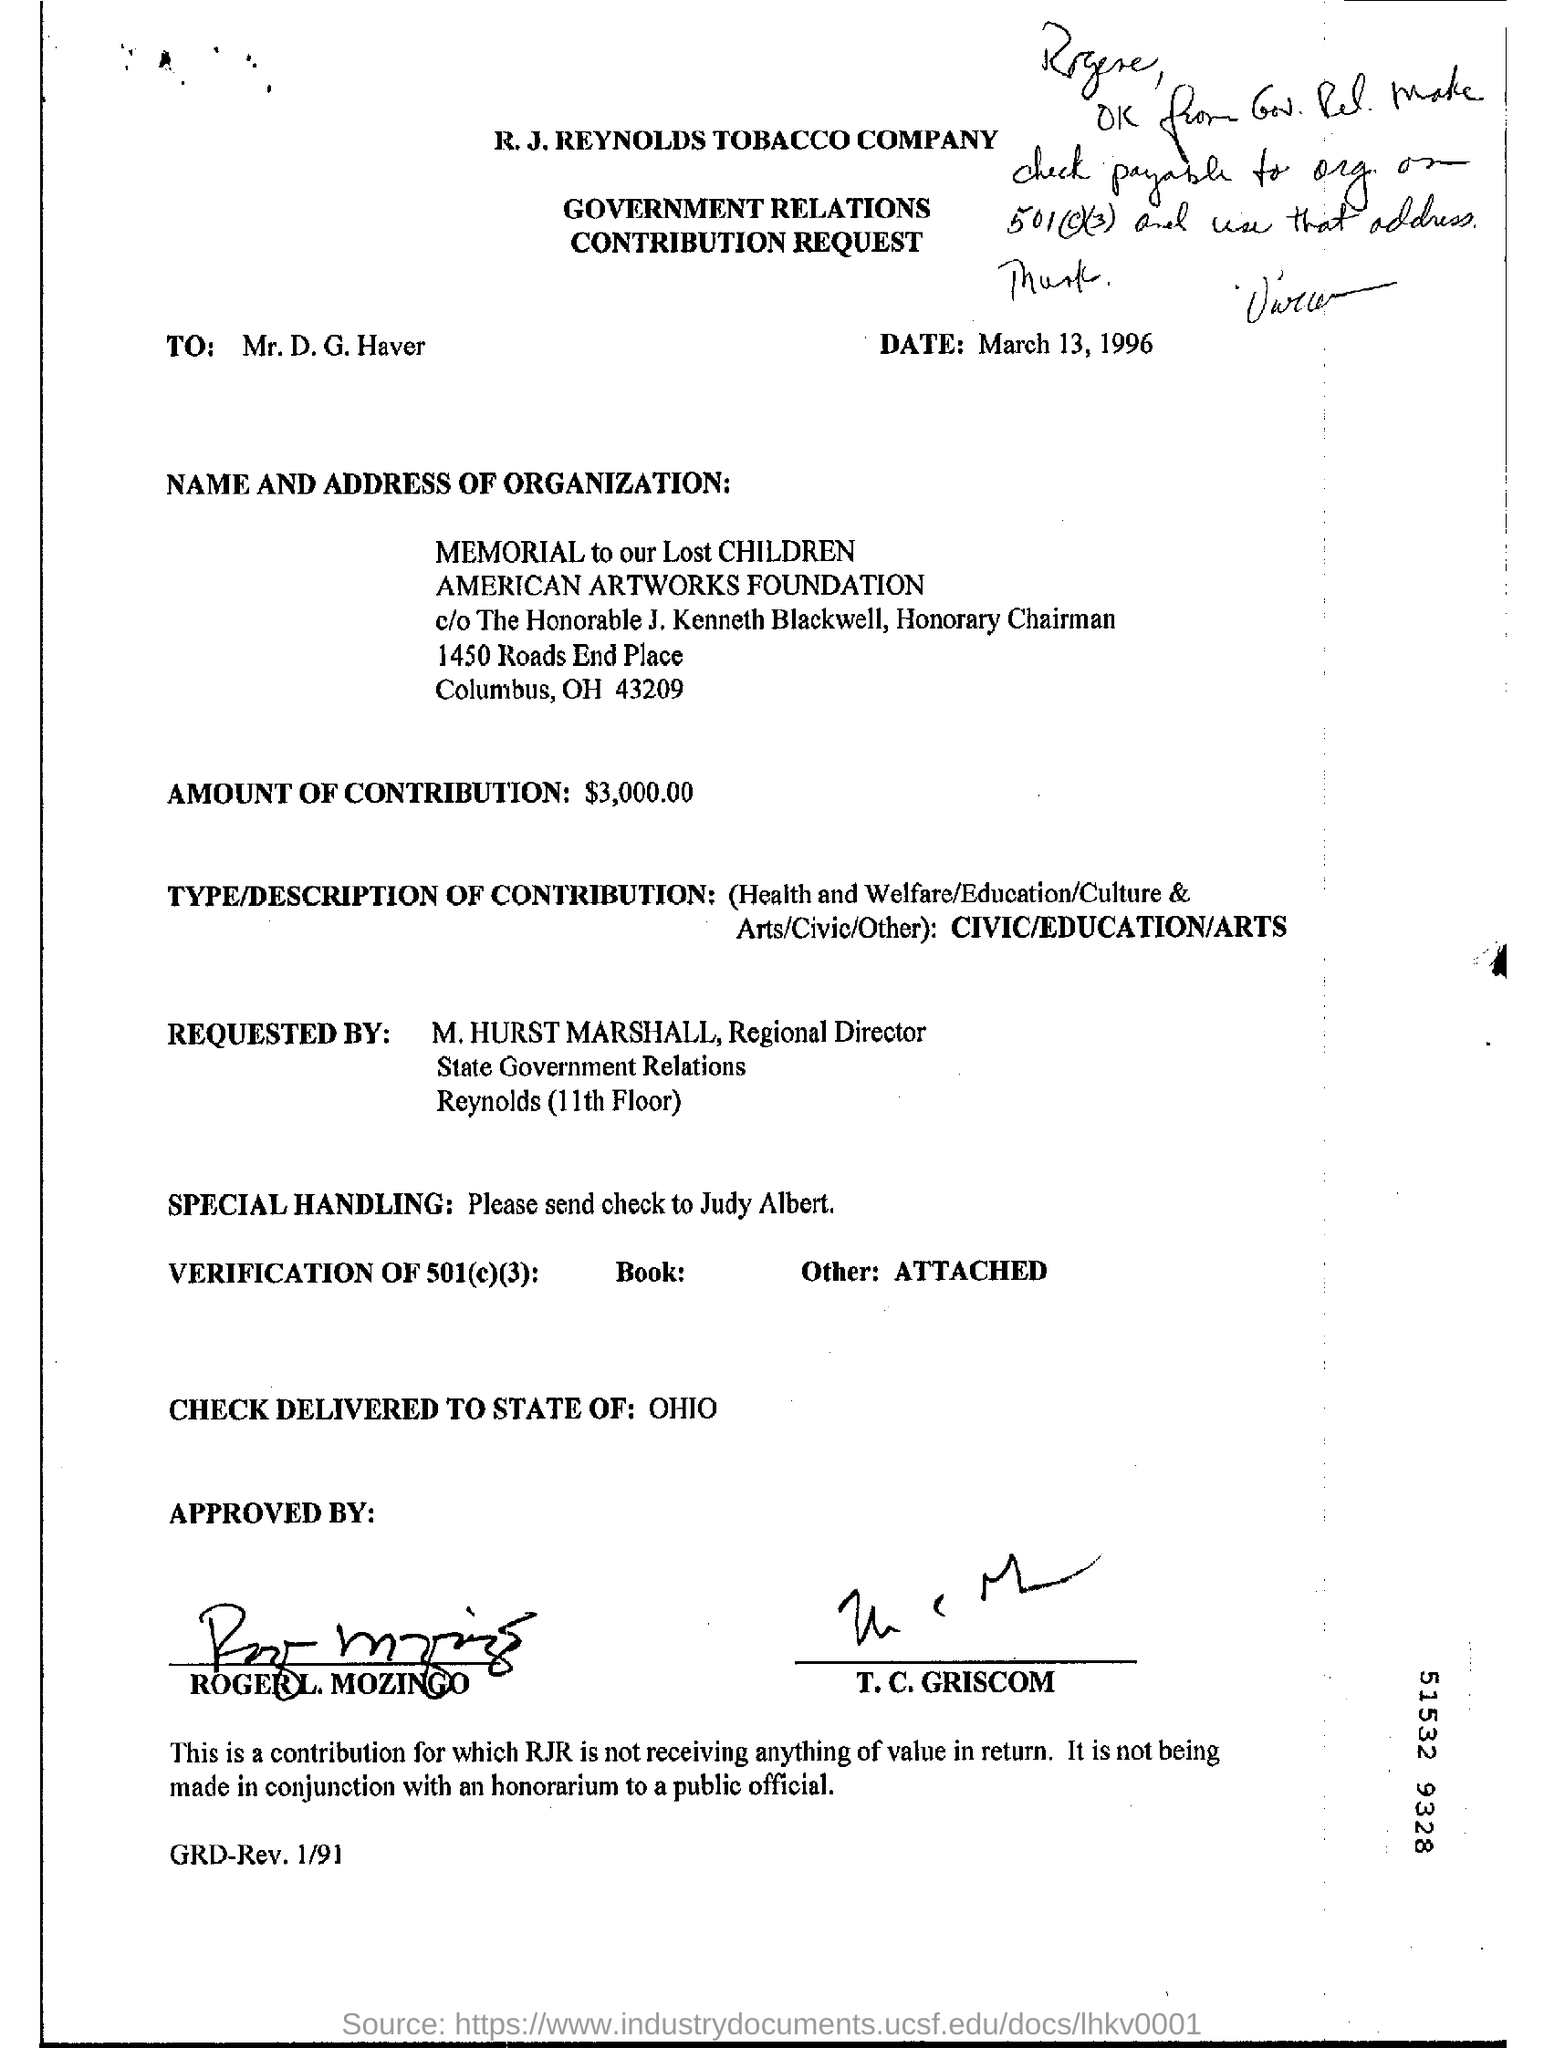To whom is the request addressed?
Make the answer very short. Mr. D. G. Haver. When is the letter dated?
Ensure brevity in your answer.  March 13, 1996. What is the postal code for "memorial to our lost children"?
Provide a succinct answer. 43209. How much is the amount of contribution?
Your answer should be compact. $3,000.00. What is the type/description of contribution?
Provide a short and direct response. CIVIC/EDUCATION/ARTS. Which state is the check delivered to?
Offer a very short reply. Ohio. 